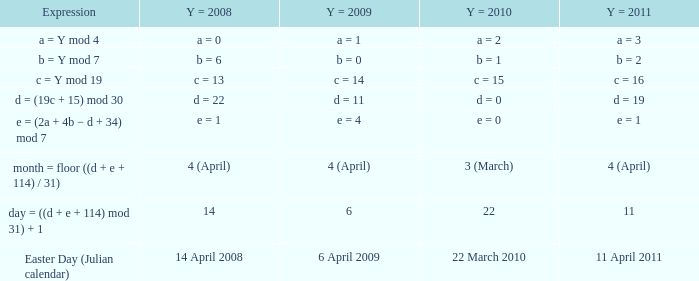What is the y = 2008 when y = 2011 is a = 3? A = 0. 